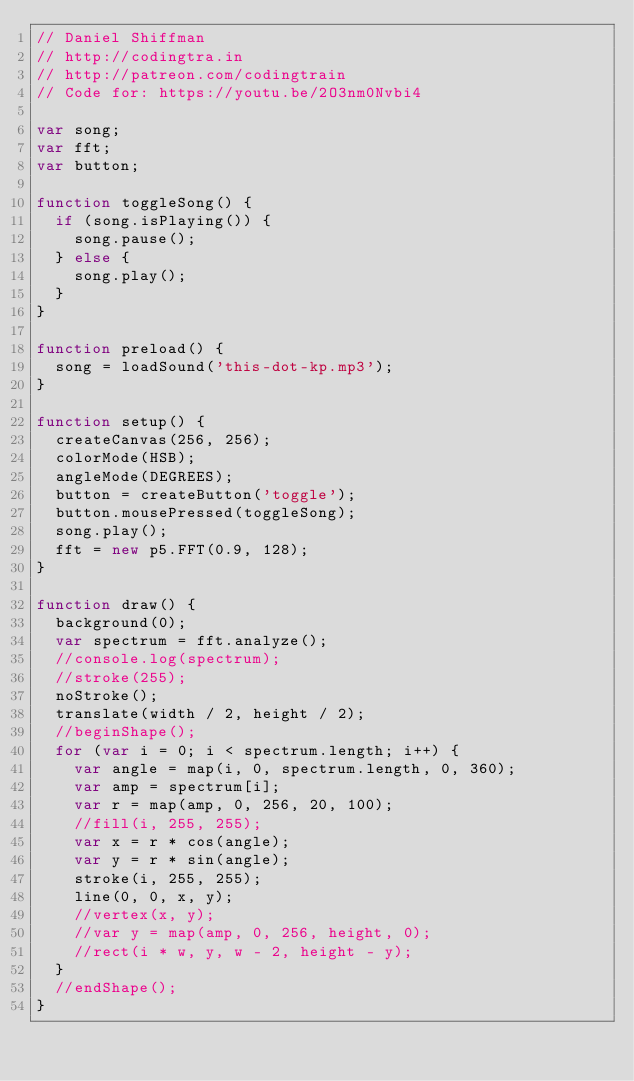<code> <loc_0><loc_0><loc_500><loc_500><_JavaScript_>// Daniel Shiffman
// http://codingtra.in
// http://patreon.com/codingtrain
// Code for: https://youtu.be/2O3nm0Nvbi4

var song;
var fft;
var button;

function toggleSong() {
  if (song.isPlaying()) {
    song.pause();
  } else {
    song.play();
  }
}

function preload() {
  song = loadSound('this-dot-kp.mp3');
}

function setup() {
  createCanvas(256, 256);
  colorMode(HSB);
  angleMode(DEGREES);
  button = createButton('toggle');
  button.mousePressed(toggleSong);
  song.play();
  fft = new p5.FFT(0.9, 128);
}

function draw() {
  background(0);
  var spectrum = fft.analyze();
  //console.log(spectrum);
  //stroke(255);
  noStroke();
  translate(width / 2, height / 2);
  //beginShape();
  for (var i = 0; i < spectrum.length; i++) {
    var angle = map(i, 0, spectrum.length, 0, 360);
    var amp = spectrum[i];
    var r = map(amp, 0, 256, 20, 100);
    //fill(i, 255, 255);
    var x = r * cos(angle);
    var y = r * sin(angle);
    stroke(i, 255, 255);
    line(0, 0, x, y);
    //vertex(x, y);
    //var y = map(amp, 0, 256, height, 0);
    //rect(i * w, y, w - 2, height - y);
  }
  //endShape();
}
</code> 